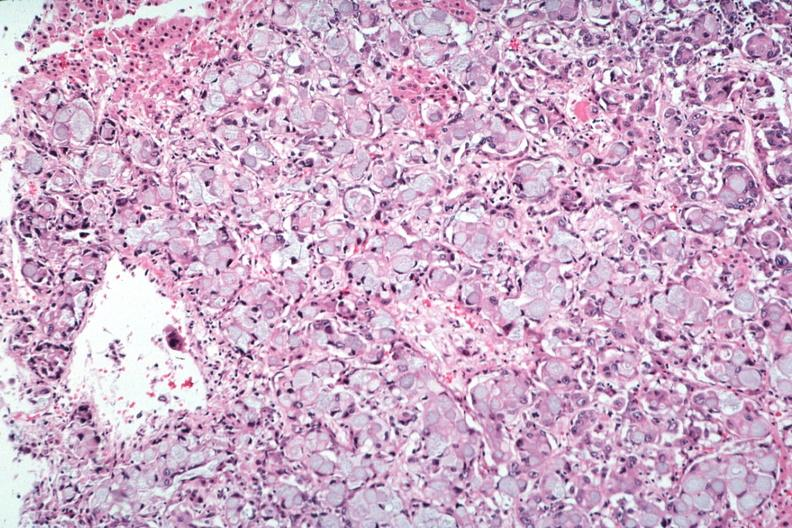s endocrine present?
Answer the question using a single word or phrase. Yes 